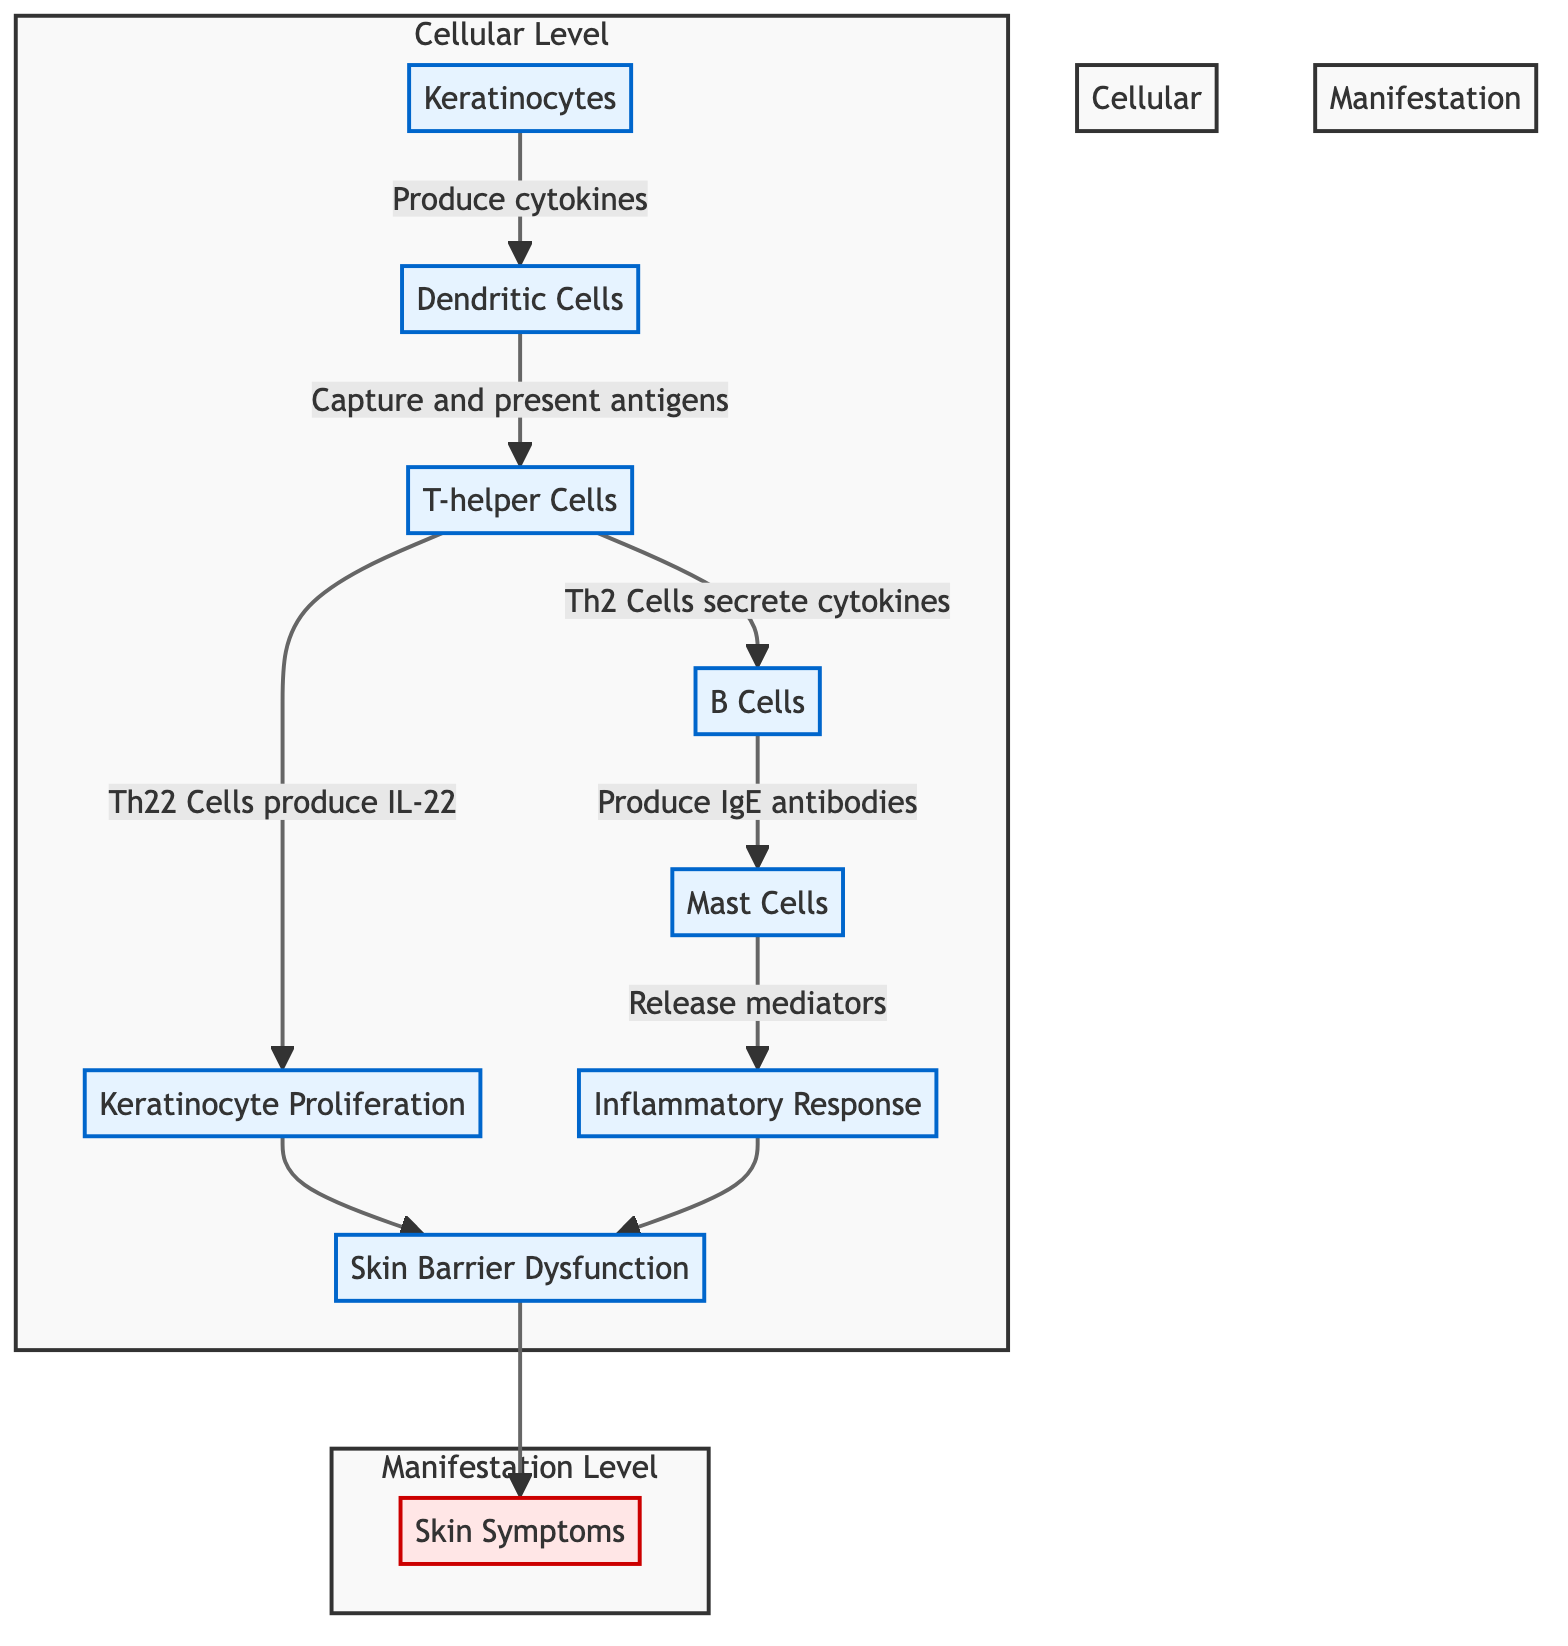What cellular level initiates the immunological response in eczema? The diagram starts with the cellular level of Keratinocytes, which produce cytokines to initiate the response.
Answer: Keratinocytes How many steps are there from Keratinocytes to Skin Symptoms in the diagram? The diagram illustrates a sequence of steps from Keratinocytes to Skin Symptoms, totaling 7 distinct nodes/steps in the process.
Answer: 7 What cytokines do Th2 Cells secrete? The diagram specifies that Th2 Cells secrete IL-4, IL-5, and IL-13 in the immunological pathway leading to eczema.
Answer: IL-4, IL-5, IL-13 Which cell type is responsible for producing IgE antibodies? In the flow chart, the B Cells are indicated as responsible for producing IgE antibodies in the immunological response.
Answer: B Cells What is the final manifestation observed in the diagram? The diagram concludes with the manifestation of Skin Symptoms, which includes multiple symptoms related to eczema.
Answer: Skin Symptoms What effect do Mast Cells have in the immunological pathway? The flow chart indicates that Mast Cells bind IgE and release mediators, leading to an Inflammatory Response.
Answer: Release mediators If there is an Inflammatory Response, what does it lead to in the diagram? The diagram shows that the Inflammatory Response has two pathways: it leads to Skin Barrier Dysfunction and also contributes to further skin manifestations.
Answer: Skin Barrier Dysfunction What do Keratinocytes amplify in response to cytokines and mediators? According to the diagram, Keratinocytes respond to cytokines and mediators by amplifying inflammation as part of the immune response to eczema.
Answer: Amplify inflammation 